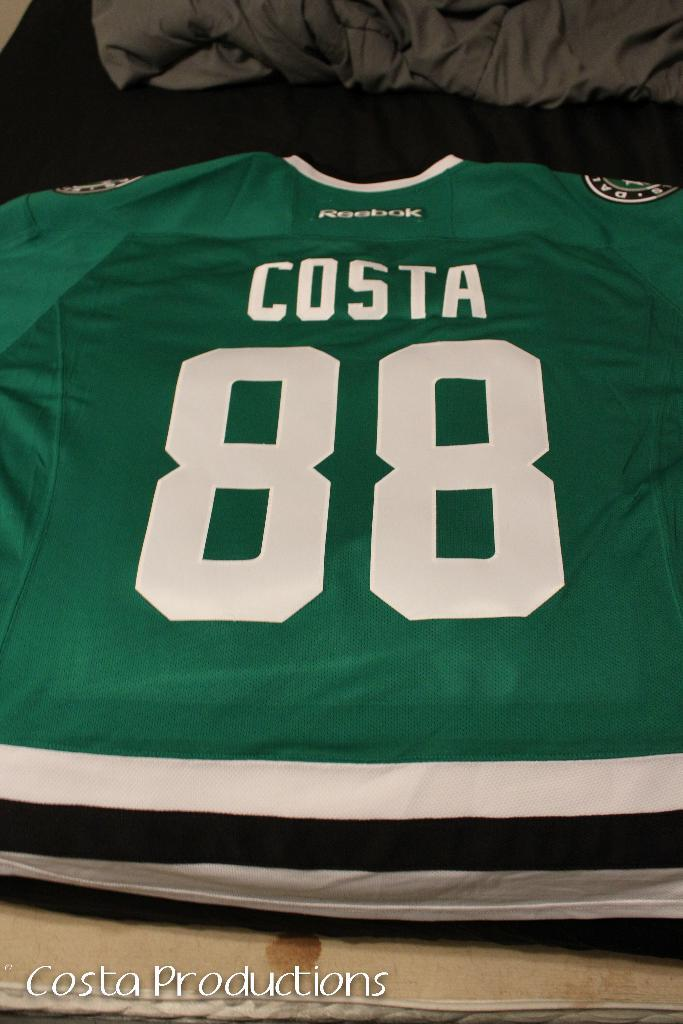<image>
Create a compact narrative representing the image presented. A green jersey has a number 88 and the name Costa. 